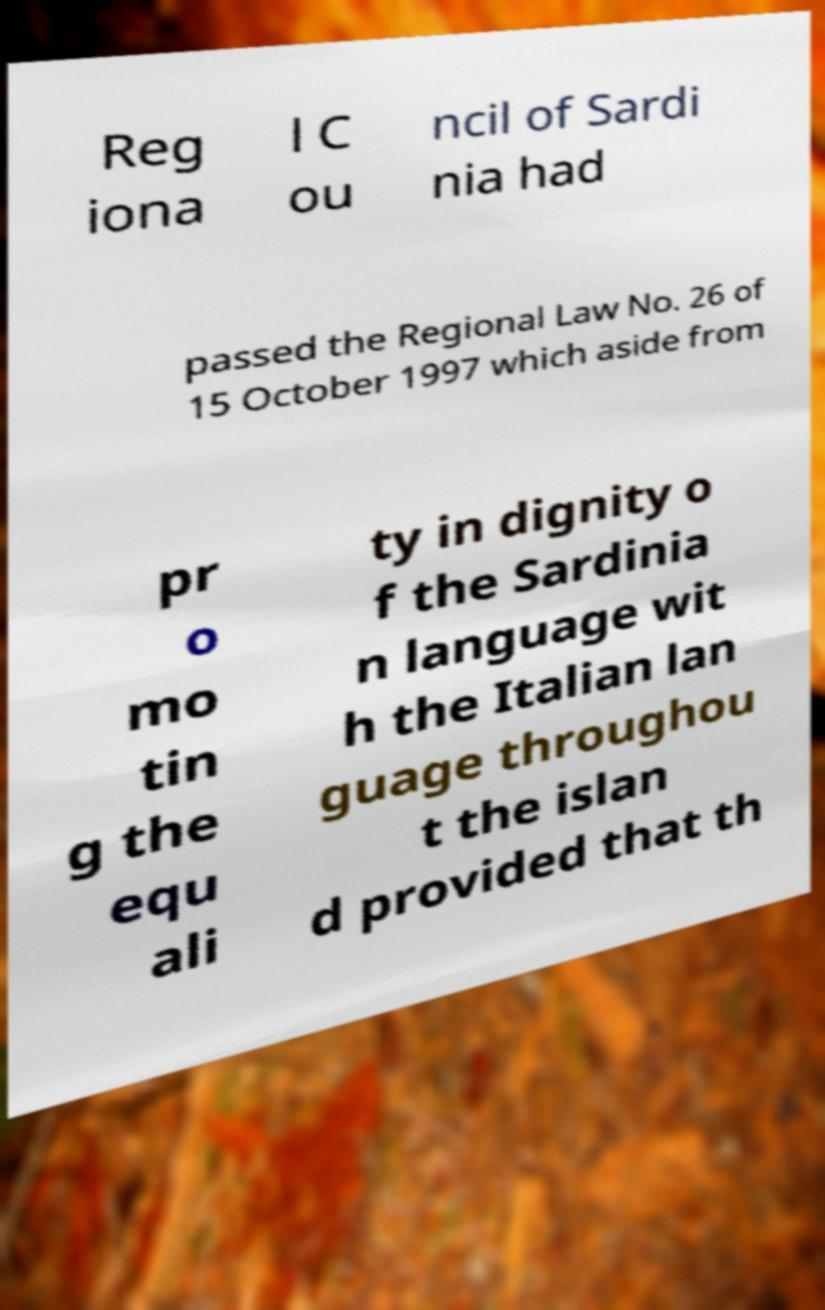What messages or text are displayed in this image? I need them in a readable, typed format. Reg iona l C ou ncil of Sardi nia had passed the Regional Law No. 26 of 15 October 1997 which aside from pr o mo tin g the equ ali ty in dignity o f the Sardinia n language wit h the Italian lan guage throughou t the islan d provided that th 